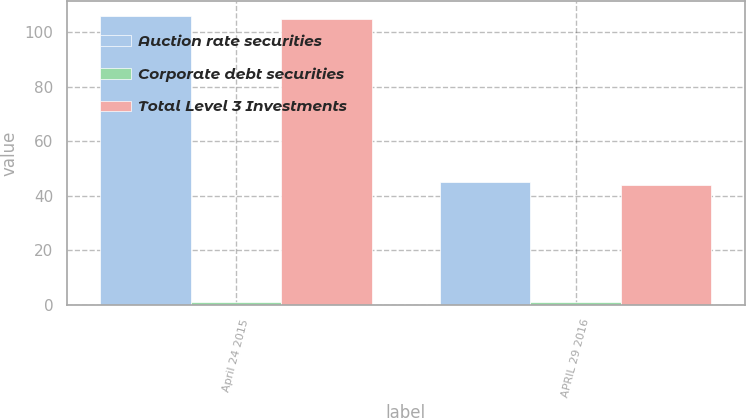Convert chart. <chart><loc_0><loc_0><loc_500><loc_500><stacked_bar_chart><ecel><fcel>April 24 2015<fcel>APRIL 29 2016<nl><fcel>Auction rate securities<fcel>106<fcel>45<nl><fcel>Corporate debt securities<fcel>1<fcel>1<nl><fcel>Total Level 3 Investments<fcel>105<fcel>44<nl></chart> 